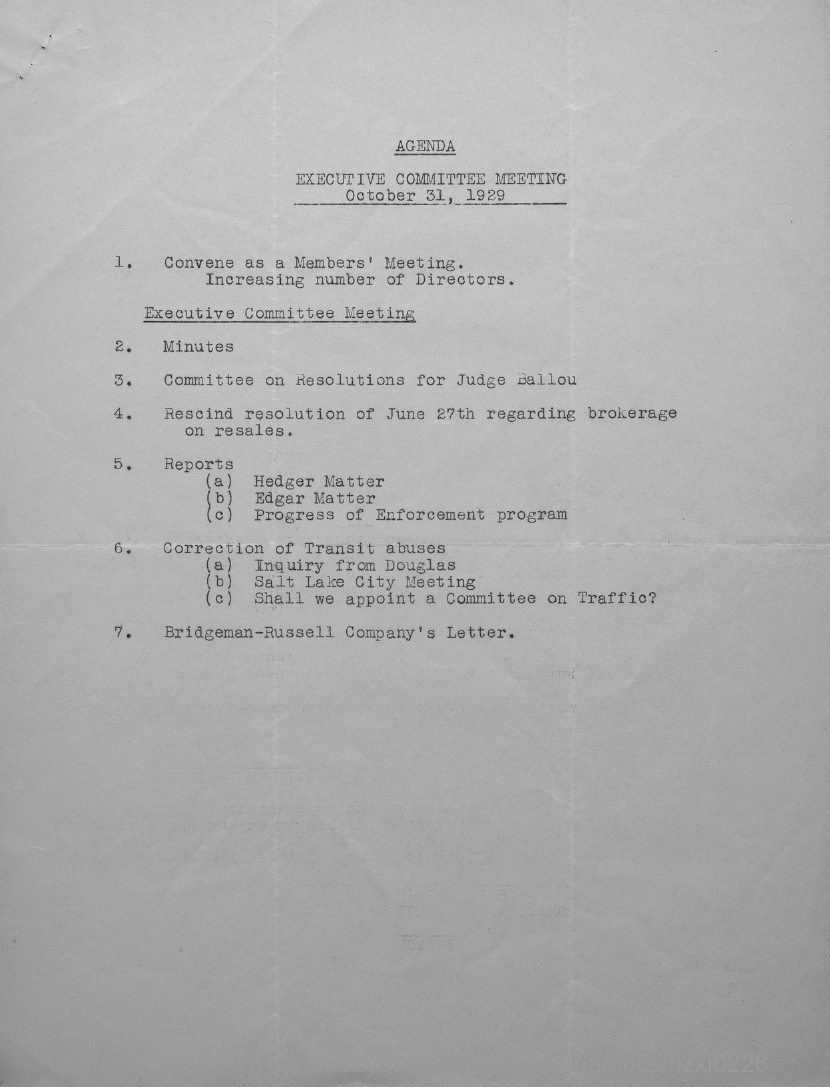When is the executive committee meeting held?
Your answer should be compact. October 31, 1929. 